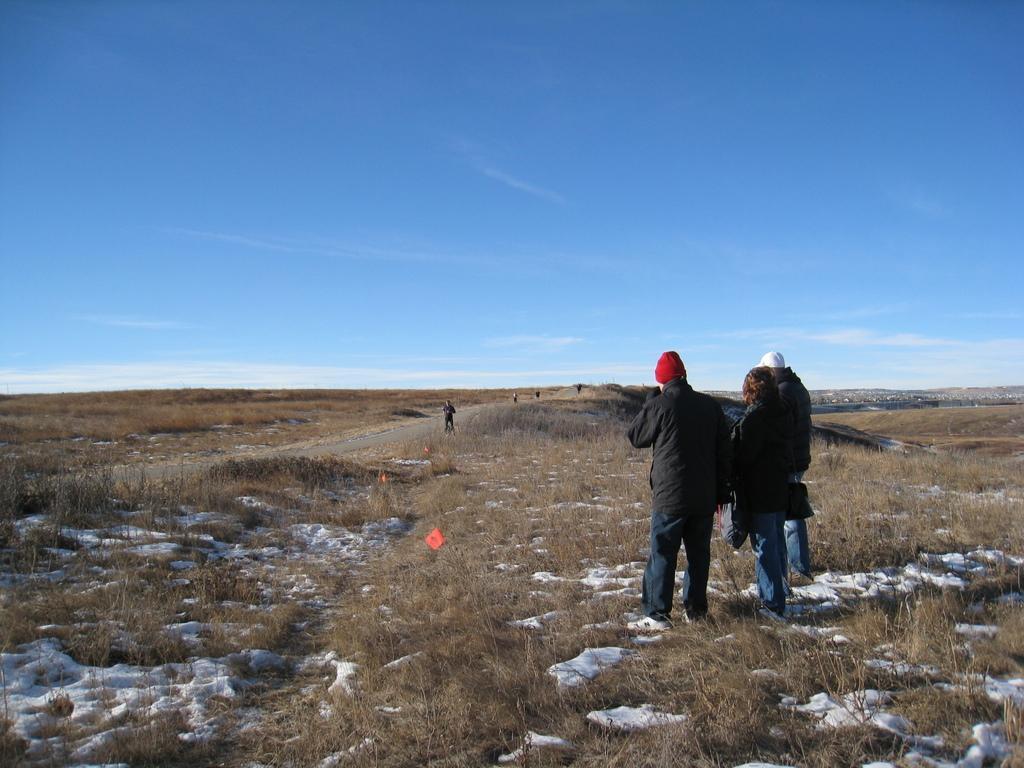Describe this image in one or two sentences. At the bottom of the image there is ground with dry grass and snow on it. Also there are three people with black jacket is standing. At the top of the image there is a blue sky. 